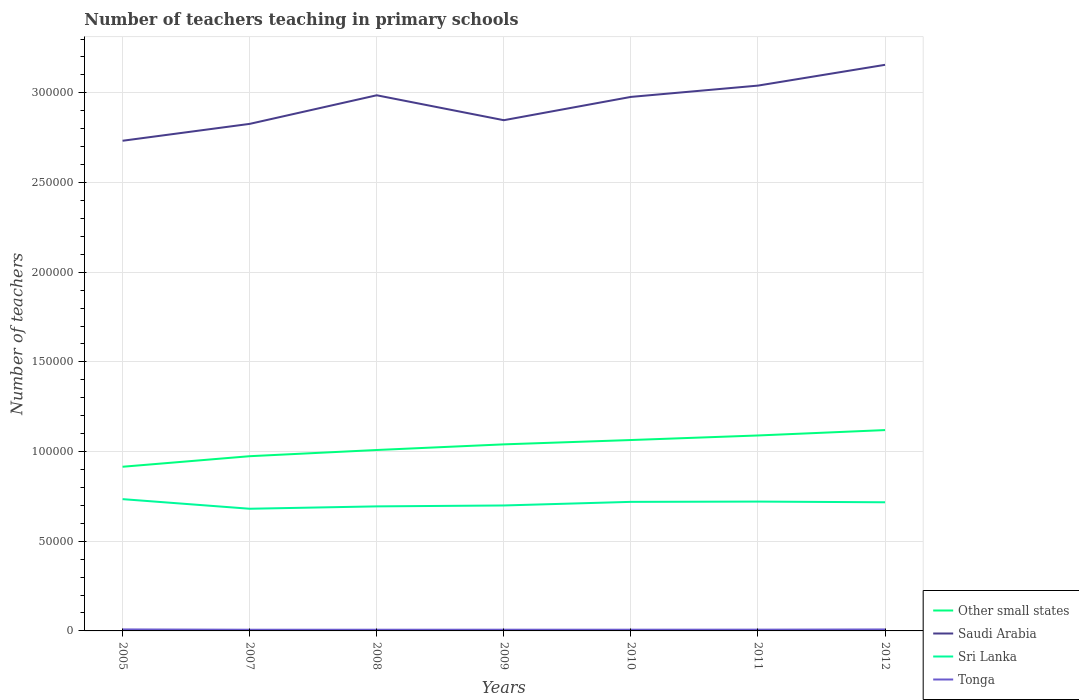How many different coloured lines are there?
Offer a very short reply. 4. Is the number of lines equal to the number of legend labels?
Give a very brief answer. Yes. Across all years, what is the maximum number of teachers teaching in primary schools in Other small states?
Your answer should be very brief. 9.15e+04. In which year was the number of teachers teaching in primary schools in Saudi Arabia maximum?
Give a very brief answer. 2005. What is the total number of teachers teaching in primary schools in Other small states in the graph?
Provide a short and direct response. -1.49e+04. What is the difference between the highest and the second highest number of teachers teaching in primary schools in Sri Lanka?
Provide a short and direct response. 5357. What is the difference between the highest and the lowest number of teachers teaching in primary schools in Saudi Arabia?
Your response must be concise. 4. Is the number of teachers teaching in primary schools in Tonga strictly greater than the number of teachers teaching in primary schools in Saudi Arabia over the years?
Your response must be concise. Yes. How many lines are there?
Your answer should be very brief. 4. How many years are there in the graph?
Make the answer very short. 7. Are the values on the major ticks of Y-axis written in scientific E-notation?
Your answer should be compact. No. Does the graph contain any zero values?
Ensure brevity in your answer.  No. Does the graph contain grids?
Keep it short and to the point. Yes. How are the legend labels stacked?
Offer a very short reply. Vertical. What is the title of the graph?
Give a very brief answer. Number of teachers teaching in primary schools. What is the label or title of the Y-axis?
Your response must be concise. Number of teachers. What is the Number of teachers of Other small states in 2005?
Your answer should be compact. 9.15e+04. What is the Number of teachers of Saudi Arabia in 2005?
Keep it short and to the point. 2.73e+05. What is the Number of teachers of Sri Lanka in 2005?
Offer a very short reply. 7.35e+04. What is the Number of teachers of Tonga in 2005?
Keep it short and to the point. 839. What is the Number of teachers in Other small states in 2007?
Your answer should be very brief. 9.74e+04. What is the Number of teachers of Saudi Arabia in 2007?
Keep it short and to the point. 2.83e+05. What is the Number of teachers in Sri Lanka in 2007?
Offer a terse response. 6.81e+04. What is the Number of teachers of Tonga in 2007?
Provide a succinct answer. 665. What is the Number of teachers of Other small states in 2008?
Ensure brevity in your answer.  1.01e+05. What is the Number of teachers in Saudi Arabia in 2008?
Give a very brief answer. 2.99e+05. What is the Number of teachers in Sri Lanka in 2008?
Keep it short and to the point. 6.94e+04. What is the Number of teachers of Tonga in 2008?
Your response must be concise. 665. What is the Number of teachers of Other small states in 2009?
Your response must be concise. 1.04e+05. What is the Number of teachers in Saudi Arabia in 2009?
Provide a succinct answer. 2.85e+05. What is the Number of teachers of Sri Lanka in 2009?
Provide a succinct answer. 6.99e+04. What is the Number of teachers of Tonga in 2009?
Keep it short and to the point. 680. What is the Number of teachers in Other small states in 2010?
Give a very brief answer. 1.06e+05. What is the Number of teachers in Saudi Arabia in 2010?
Your answer should be compact. 2.98e+05. What is the Number of teachers of Sri Lanka in 2010?
Your answer should be compact. 7.20e+04. What is the Number of teachers in Tonga in 2010?
Your response must be concise. 677. What is the Number of teachers of Other small states in 2011?
Provide a short and direct response. 1.09e+05. What is the Number of teachers in Saudi Arabia in 2011?
Offer a terse response. 3.04e+05. What is the Number of teachers of Sri Lanka in 2011?
Offer a very short reply. 7.21e+04. What is the Number of teachers in Tonga in 2011?
Keep it short and to the point. 706. What is the Number of teachers in Other small states in 2012?
Give a very brief answer. 1.12e+05. What is the Number of teachers of Saudi Arabia in 2012?
Ensure brevity in your answer.  3.16e+05. What is the Number of teachers of Sri Lanka in 2012?
Your answer should be compact. 7.17e+04. What is the Number of teachers in Tonga in 2012?
Give a very brief answer. 816. Across all years, what is the maximum Number of teachers in Other small states?
Offer a terse response. 1.12e+05. Across all years, what is the maximum Number of teachers in Saudi Arabia?
Offer a terse response. 3.16e+05. Across all years, what is the maximum Number of teachers of Sri Lanka?
Offer a terse response. 7.35e+04. Across all years, what is the maximum Number of teachers of Tonga?
Your response must be concise. 839. Across all years, what is the minimum Number of teachers in Other small states?
Ensure brevity in your answer.  9.15e+04. Across all years, what is the minimum Number of teachers of Saudi Arabia?
Provide a short and direct response. 2.73e+05. Across all years, what is the minimum Number of teachers in Sri Lanka?
Your answer should be very brief. 6.81e+04. Across all years, what is the minimum Number of teachers in Tonga?
Your answer should be compact. 665. What is the total Number of teachers of Other small states in the graph?
Ensure brevity in your answer.  7.21e+05. What is the total Number of teachers of Saudi Arabia in the graph?
Provide a short and direct response. 2.06e+06. What is the total Number of teachers in Sri Lanka in the graph?
Your answer should be very brief. 4.97e+05. What is the total Number of teachers of Tonga in the graph?
Your answer should be compact. 5048. What is the difference between the Number of teachers in Other small states in 2005 and that in 2007?
Your answer should be very brief. -5878.77. What is the difference between the Number of teachers in Saudi Arabia in 2005 and that in 2007?
Your answer should be compact. -9409. What is the difference between the Number of teachers in Sri Lanka in 2005 and that in 2007?
Give a very brief answer. 5357. What is the difference between the Number of teachers in Tonga in 2005 and that in 2007?
Give a very brief answer. 174. What is the difference between the Number of teachers in Other small states in 2005 and that in 2008?
Make the answer very short. -9336.92. What is the difference between the Number of teachers in Saudi Arabia in 2005 and that in 2008?
Make the answer very short. -2.54e+04. What is the difference between the Number of teachers of Sri Lanka in 2005 and that in 2008?
Provide a succinct answer. 4035. What is the difference between the Number of teachers in Tonga in 2005 and that in 2008?
Keep it short and to the point. 174. What is the difference between the Number of teachers of Other small states in 2005 and that in 2009?
Your answer should be very brief. -1.25e+04. What is the difference between the Number of teachers in Saudi Arabia in 2005 and that in 2009?
Your response must be concise. -1.15e+04. What is the difference between the Number of teachers of Sri Lanka in 2005 and that in 2009?
Your answer should be compact. 3523. What is the difference between the Number of teachers of Tonga in 2005 and that in 2009?
Your answer should be very brief. 159. What is the difference between the Number of teachers in Other small states in 2005 and that in 2010?
Provide a succinct answer. -1.49e+04. What is the difference between the Number of teachers in Saudi Arabia in 2005 and that in 2010?
Ensure brevity in your answer.  -2.44e+04. What is the difference between the Number of teachers in Sri Lanka in 2005 and that in 2010?
Make the answer very short. 1514. What is the difference between the Number of teachers in Tonga in 2005 and that in 2010?
Ensure brevity in your answer.  162. What is the difference between the Number of teachers in Other small states in 2005 and that in 2011?
Your response must be concise. -1.74e+04. What is the difference between the Number of teachers in Saudi Arabia in 2005 and that in 2011?
Your response must be concise. -3.08e+04. What is the difference between the Number of teachers in Sri Lanka in 2005 and that in 2011?
Your answer should be very brief. 1357. What is the difference between the Number of teachers in Tonga in 2005 and that in 2011?
Give a very brief answer. 133. What is the difference between the Number of teachers in Other small states in 2005 and that in 2012?
Your response must be concise. -2.04e+04. What is the difference between the Number of teachers in Saudi Arabia in 2005 and that in 2012?
Your response must be concise. -4.23e+04. What is the difference between the Number of teachers of Sri Lanka in 2005 and that in 2012?
Keep it short and to the point. 1750. What is the difference between the Number of teachers of Tonga in 2005 and that in 2012?
Provide a succinct answer. 23. What is the difference between the Number of teachers in Other small states in 2007 and that in 2008?
Provide a short and direct response. -3458.15. What is the difference between the Number of teachers in Saudi Arabia in 2007 and that in 2008?
Your answer should be compact. -1.59e+04. What is the difference between the Number of teachers in Sri Lanka in 2007 and that in 2008?
Your answer should be very brief. -1322. What is the difference between the Number of teachers of Other small states in 2007 and that in 2009?
Give a very brief answer. -6601.63. What is the difference between the Number of teachers of Saudi Arabia in 2007 and that in 2009?
Provide a short and direct response. -2053. What is the difference between the Number of teachers in Sri Lanka in 2007 and that in 2009?
Provide a succinct answer. -1834. What is the difference between the Number of teachers in Tonga in 2007 and that in 2009?
Your answer should be compact. -15. What is the difference between the Number of teachers of Other small states in 2007 and that in 2010?
Ensure brevity in your answer.  -9015.43. What is the difference between the Number of teachers of Saudi Arabia in 2007 and that in 2010?
Ensure brevity in your answer.  -1.50e+04. What is the difference between the Number of teachers in Sri Lanka in 2007 and that in 2010?
Your answer should be very brief. -3843. What is the difference between the Number of teachers of Other small states in 2007 and that in 2011?
Provide a short and direct response. -1.16e+04. What is the difference between the Number of teachers of Saudi Arabia in 2007 and that in 2011?
Your answer should be compact. -2.13e+04. What is the difference between the Number of teachers in Sri Lanka in 2007 and that in 2011?
Offer a very short reply. -4000. What is the difference between the Number of teachers of Tonga in 2007 and that in 2011?
Keep it short and to the point. -41. What is the difference between the Number of teachers of Other small states in 2007 and that in 2012?
Keep it short and to the point. -1.46e+04. What is the difference between the Number of teachers of Saudi Arabia in 2007 and that in 2012?
Make the answer very short. -3.29e+04. What is the difference between the Number of teachers of Sri Lanka in 2007 and that in 2012?
Provide a short and direct response. -3607. What is the difference between the Number of teachers in Tonga in 2007 and that in 2012?
Keep it short and to the point. -151. What is the difference between the Number of teachers of Other small states in 2008 and that in 2009?
Provide a succinct answer. -3143.48. What is the difference between the Number of teachers in Saudi Arabia in 2008 and that in 2009?
Provide a short and direct response. 1.39e+04. What is the difference between the Number of teachers in Sri Lanka in 2008 and that in 2009?
Give a very brief answer. -512. What is the difference between the Number of teachers in Tonga in 2008 and that in 2009?
Your response must be concise. -15. What is the difference between the Number of teachers of Other small states in 2008 and that in 2010?
Ensure brevity in your answer.  -5557.28. What is the difference between the Number of teachers in Saudi Arabia in 2008 and that in 2010?
Your answer should be very brief. 907. What is the difference between the Number of teachers in Sri Lanka in 2008 and that in 2010?
Your response must be concise. -2521. What is the difference between the Number of teachers of Other small states in 2008 and that in 2011?
Offer a terse response. -8101.96. What is the difference between the Number of teachers in Saudi Arabia in 2008 and that in 2011?
Keep it short and to the point. -5397. What is the difference between the Number of teachers of Sri Lanka in 2008 and that in 2011?
Provide a succinct answer. -2678. What is the difference between the Number of teachers of Tonga in 2008 and that in 2011?
Your response must be concise. -41. What is the difference between the Number of teachers of Other small states in 2008 and that in 2012?
Make the answer very short. -1.11e+04. What is the difference between the Number of teachers of Saudi Arabia in 2008 and that in 2012?
Provide a succinct answer. -1.70e+04. What is the difference between the Number of teachers in Sri Lanka in 2008 and that in 2012?
Keep it short and to the point. -2285. What is the difference between the Number of teachers of Tonga in 2008 and that in 2012?
Provide a short and direct response. -151. What is the difference between the Number of teachers of Other small states in 2009 and that in 2010?
Give a very brief answer. -2413.8. What is the difference between the Number of teachers in Saudi Arabia in 2009 and that in 2010?
Provide a succinct answer. -1.30e+04. What is the difference between the Number of teachers in Sri Lanka in 2009 and that in 2010?
Your response must be concise. -2009. What is the difference between the Number of teachers of Tonga in 2009 and that in 2010?
Give a very brief answer. 3. What is the difference between the Number of teachers of Other small states in 2009 and that in 2011?
Provide a succinct answer. -4958.48. What is the difference between the Number of teachers of Saudi Arabia in 2009 and that in 2011?
Provide a succinct answer. -1.93e+04. What is the difference between the Number of teachers of Sri Lanka in 2009 and that in 2011?
Offer a very short reply. -2166. What is the difference between the Number of teachers in Tonga in 2009 and that in 2011?
Your response must be concise. -26. What is the difference between the Number of teachers in Other small states in 2009 and that in 2012?
Provide a succinct answer. -7964.37. What is the difference between the Number of teachers in Saudi Arabia in 2009 and that in 2012?
Offer a very short reply. -3.09e+04. What is the difference between the Number of teachers in Sri Lanka in 2009 and that in 2012?
Provide a succinct answer. -1773. What is the difference between the Number of teachers in Tonga in 2009 and that in 2012?
Offer a terse response. -136. What is the difference between the Number of teachers in Other small states in 2010 and that in 2011?
Your answer should be compact. -2544.68. What is the difference between the Number of teachers in Saudi Arabia in 2010 and that in 2011?
Your answer should be very brief. -6304. What is the difference between the Number of teachers of Sri Lanka in 2010 and that in 2011?
Ensure brevity in your answer.  -157. What is the difference between the Number of teachers of Other small states in 2010 and that in 2012?
Keep it short and to the point. -5550.57. What is the difference between the Number of teachers of Saudi Arabia in 2010 and that in 2012?
Offer a terse response. -1.79e+04. What is the difference between the Number of teachers in Sri Lanka in 2010 and that in 2012?
Your answer should be compact. 236. What is the difference between the Number of teachers in Tonga in 2010 and that in 2012?
Provide a succinct answer. -139. What is the difference between the Number of teachers of Other small states in 2011 and that in 2012?
Offer a very short reply. -3005.89. What is the difference between the Number of teachers in Saudi Arabia in 2011 and that in 2012?
Offer a very short reply. -1.16e+04. What is the difference between the Number of teachers in Sri Lanka in 2011 and that in 2012?
Your answer should be compact. 393. What is the difference between the Number of teachers of Tonga in 2011 and that in 2012?
Your answer should be very brief. -110. What is the difference between the Number of teachers in Other small states in 2005 and the Number of teachers in Saudi Arabia in 2007?
Keep it short and to the point. -1.91e+05. What is the difference between the Number of teachers in Other small states in 2005 and the Number of teachers in Sri Lanka in 2007?
Your answer should be very brief. 2.34e+04. What is the difference between the Number of teachers in Other small states in 2005 and the Number of teachers in Tonga in 2007?
Provide a succinct answer. 9.09e+04. What is the difference between the Number of teachers of Saudi Arabia in 2005 and the Number of teachers of Sri Lanka in 2007?
Provide a short and direct response. 2.05e+05. What is the difference between the Number of teachers of Saudi Arabia in 2005 and the Number of teachers of Tonga in 2007?
Provide a succinct answer. 2.73e+05. What is the difference between the Number of teachers in Sri Lanka in 2005 and the Number of teachers in Tonga in 2007?
Your response must be concise. 7.28e+04. What is the difference between the Number of teachers of Other small states in 2005 and the Number of teachers of Saudi Arabia in 2008?
Your answer should be very brief. -2.07e+05. What is the difference between the Number of teachers of Other small states in 2005 and the Number of teachers of Sri Lanka in 2008?
Provide a succinct answer. 2.21e+04. What is the difference between the Number of teachers in Other small states in 2005 and the Number of teachers in Tonga in 2008?
Ensure brevity in your answer.  9.09e+04. What is the difference between the Number of teachers of Saudi Arabia in 2005 and the Number of teachers of Sri Lanka in 2008?
Your answer should be very brief. 2.04e+05. What is the difference between the Number of teachers in Saudi Arabia in 2005 and the Number of teachers in Tonga in 2008?
Ensure brevity in your answer.  2.73e+05. What is the difference between the Number of teachers of Sri Lanka in 2005 and the Number of teachers of Tonga in 2008?
Give a very brief answer. 7.28e+04. What is the difference between the Number of teachers of Other small states in 2005 and the Number of teachers of Saudi Arabia in 2009?
Ensure brevity in your answer.  -1.93e+05. What is the difference between the Number of teachers in Other small states in 2005 and the Number of teachers in Sri Lanka in 2009?
Make the answer very short. 2.16e+04. What is the difference between the Number of teachers of Other small states in 2005 and the Number of teachers of Tonga in 2009?
Make the answer very short. 9.09e+04. What is the difference between the Number of teachers of Saudi Arabia in 2005 and the Number of teachers of Sri Lanka in 2009?
Ensure brevity in your answer.  2.03e+05. What is the difference between the Number of teachers of Saudi Arabia in 2005 and the Number of teachers of Tonga in 2009?
Ensure brevity in your answer.  2.73e+05. What is the difference between the Number of teachers in Sri Lanka in 2005 and the Number of teachers in Tonga in 2009?
Your response must be concise. 7.28e+04. What is the difference between the Number of teachers of Other small states in 2005 and the Number of teachers of Saudi Arabia in 2010?
Your answer should be very brief. -2.06e+05. What is the difference between the Number of teachers in Other small states in 2005 and the Number of teachers in Sri Lanka in 2010?
Make the answer very short. 1.96e+04. What is the difference between the Number of teachers in Other small states in 2005 and the Number of teachers in Tonga in 2010?
Provide a short and direct response. 9.09e+04. What is the difference between the Number of teachers of Saudi Arabia in 2005 and the Number of teachers of Sri Lanka in 2010?
Ensure brevity in your answer.  2.01e+05. What is the difference between the Number of teachers in Saudi Arabia in 2005 and the Number of teachers in Tonga in 2010?
Ensure brevity in your answer.  2.73e+05. What is the difference between the Number of teachers of Sri Lanka in 2005 and the Number of teachers of Tonga in 2010?
Offer a very short reply. 7.28e+04. What is the difference between the Number of teachers in Other small states in 2005 and the Number of teachers in Saudi Arabia in 2011?
Provide a short and direct response. -2.13e+05. What is the difference between the Number of teachers of Other small states in 2005 and the Number of teachers of Sri Lanka in 2011?
Provide a succinct answer. 1.94e+04. What is the difference between the Number of teachers in Other small states in 2005 and the Number of teachers in Tonga in 2011?
Your answer should be very brief. 9.08e+04. What is the difference between the Number of teachers of Saudi Arabia in 2005 and the Number of teachers of Sri Lanka in 2011?
Keep it short and to the point. 2.01e+05. What is the difference between the Number of teachers of Saudi Arabia in 2005 and the Number of teachers of Tonga in 2011?
Your answer should be compact. 2.73e+05. What is the difference between the Number of teachers of Sri Lanka in 2005 and the Number of teachers of Tonga in 2011?
Your response must be concise. 7.28e+04. What is the difference between the Number of teachers in Other small states in 2005 and the Number of teachers in Saudi Arabia in 2012?
Make the answer very short. -2.24e+05. What is the difference between the Number of teachers in Other small states in 2005 and the Number of teachers in Sri Lanka in 2012?
Make the answer very short. 1.98e+04. What is the difference between the Number of teachers in Other small states in 2005 and the Number of teachers in Tonga in 2012?
Provide a short and direct response. 9.07e+04. What is the difference between the Number of teachers in Saudi Arabia in 2005 and the Number of teachers in Sri Lanka in 2012?
Your response must be concise. 2.02e+05. What is the difference between the Number of teachers of Saudi Arabia in 2005 and the Number of teachers of Tonga in 2012?
Give a very brief answer. 2.72e+05. What is the difference between the Number of teachers in Sri Lanka in 2005 and the Number of teachers in Tonga in 2012?
Offer a terse response. 7.27e+04. What is the difference between the Number of teachers in Other small states in 2007 and the Number of teachers in Saudi Arabia in 2008?
Your answer should be very brief. -2.01e+05. What is the difference between the Number of teachers in Other small states in 2007 and the Number of teachers in Sri Lanka in 2008?
Give a very brief answer. 2.80e+04. What is the difference between the Number of teachers in Other small states in 2007 and the Number of teachers in Tonga in 2008?
Give a very brief answer. 9.67e+04. What is the difference between the Number of teachers of Saudi Arabia in 2007 and the Number of teachers of Sri Lanka in 2008?
Your response must be concise. 2.13e+05. What is the difference between the Number of teachers of Saudi Arabia in 2007 and the Number of teachers of Tonga in 2008?
Ensure brevity in your answer.  2.82e+05. What is the difference between the Number of teachers in Sri Lanka in 2007 and the Number of teachers in Tonga in 2008?
Ensure brevity in your answer.  6.74e+04. What is the difference between the Number of teachers in Other small states in 2007 and the Number of teachers in Saudi Arabia in 2009?
Your response must be concise. -1.87e+05. What is the difference between the Number of teachers of Other small states in 2007 and the Number of teachers of Sri Lanka in 2009?
Give a very brief answer. 2.75e+04. What is the difference between the Number of teachers of Other small states in 2007 and the Number of teachers of Tonga in 2009?
Provide a succinct answer. 9.67e+04. What is the difference between the Number of teachers of Saudi Arabia in 2007 and the Number of teachers of Sri Lanka in 2009?
Ensure brevity in your answer.  2.13e+05. What is the difference between the Number of teachers of Saudi Arabia in 2007 and the Number of teachers of Tonga in 2009?
Your answer should be compact. 2.82e+05. What is the difference between the Number of teachers in Sri Lanka in 2007 and the Number of teachers in Tonga in 2009?
Your answer should be compact. 6.74e+04. What is the difference between the Number of teachers in Other small states in 2007 and the Number of teachers in Saudi Arabia in 2010?
Provide a succinct answer. -2.00e+05. What is the difference between the Number of teachers in Other small states in 2007 and the Number of teachers in Sri Lanka in 2010?
Make the answer very short. 2.55e+04. What is the difference between the Number of teachers of Other small states in 2007 and the Number of teachers of Tonga in 2010?
Make the answer very short. 9.67e+04. What is the difference between the Number of teachers of Saudi Arabia in 2007 and the Number of teachers of Sri Lanka in 2010?
Make the answer very short. 2.11e+05. What is the difference between the Number of teachers in Saudi Arabia in 2007 and the Number of teachers in Tonga in 2010?
Your answer should be very brief. 2.82e+05. What is the difference between the Number of teachers in Sri Lanka in 2007 and the Number of teachers in Tonga in 2010?
Your answer should be very brief. 6.74e+04. What is the difference between the Number of teachers of Other small states in 2007 and the Number of teachers of Saudi Arabia in 2011?
Keep it short and to the point. -2.07e+05. What is the difference between the Number of teachers of Other small states in 2007 and the Number of teachers of Sri Lanka in 2011?
Offer a terse response. 2.53e+04. What is the difference between the Number of teachers of Other small states in 2007 and the Number of teachers of Tonga in 2011?
Your response must be concise. 9.67e+04. What is the difference between the Number of teachers in Saudi Arabia in 2007 and the Number of teachers in Sri Lanka in 2011?
Provide a short and direct response. 2.11e+05. What is the difference between the Number of teachers of Saudi Arabia in 2007 and the Number of teachers of Tonga in 2011?
Offer a terse response. 2.82e+05. What is the difference between the Number of teachers of Sri Lanka in 2007 and the Number of teachers of Tonga in 2011?
Ensure brevity in your answer.  6.74e+04. What is the difference between the Number of teachers in Other small states in 2007 and the Number of teachers in Saudi Arabia in 2012?
Make the answer very short. -2.18e+05. What is the difference between the Number of teachers in Other small states in 2007 and the Number of teachers in Sri Lanka in 2012?
Offer a very short reply. 2.57e+04. What is the difference between the Number of teachers of Other small states in 2007 and the Number of teachers of Tonga in 2012?
Your response must be concise. 9.66e+04. What is the difference between the Number of teachers of Saudi Arabia in 2007 and the Number of teachers of Sri Lanka in 2012?
Make the answer very short. 2.11e+05. What is the difference between the Number of teachers in Saudi Arabia in 2007 and the Number of teachers in Tonga in 2012?
Your answer should be compact. 2.82e+05. What is the difference between the Number of teachers in Sri Lanka in 2007 and the Number of teachers in Tonga in 2012?
Give a very brief answer. 6.73e+04. What is the difference between the Number of teachers in Other small states in 2008 and the Number of teachers in Saudi Arabia in 2009?
Your response must be concise. -1.84e+05. What is the difference between the Number of teachers in Other small states in 2008 and the Number of teachers in Sri Lanka in 2009?
Provide a short and direct response. 3.09e+04. What is the difference between the Number of teachers of Other small states in 2008 and the Number of teachers of Tonga in 2009?
Provide a short and direct response. 1.00e+05. What is the difference between the Number of teachers of Saudi Arabia in 2008 and the Number of teachers of Sri Lanka in 2009?
Your response must be concise. 2.29e+05. What is the difference between the Number of teachers in Saudi Arabia in 2008 and the Number of teachers in Tonga in 2009?
Give a very brief answer. 2.98e+05. What is the difference between the Number of teachers in Sri Lanka in 2008 and the Number of teachers in Tonga in 2009?
Provide a short and direct response. 6.88e+04. What is the difference between the Number of teachers in Other small states in 2008 and the Number of teachers in Saudi Arabia in 2010?
Provide a succinct answer. -1.97e+05. What is the difference between the Number of teachers of Other small states in 2008 and the Number of teachers of Sri Lanka in 2010?
Ensure brevity in your answer.  2.89e+04. What is the difference between the Number of teachers of Other small states in 2008 and the Number of teachers of Tonga in 2010?
Provide a short and direct response. 1.00e+05. What is the difference between the Number of teachers in Saudi Arabia in 2008 and the Number of teachers in Sri Lanka in 2010?
Your answer should be compact. 2.27e+05. What is the difference between the Number of teachers in Saudi Arabia in 2008 and the Number of teachers in Tonga in 2010?
Ensure brevity in your answer.  2.98e+05. What is the difference between the Number of teachers of Sri Lanka in 2008 and the Number of teachers of Tonga in 2010?
Keep it short and to the point. 6.88e+04. What is the difference between the Number of teachers in Other small states in 2008 and the Number of teachers in Saudi Arabia in 2011?
Give a very brief answer. -2.03e+05. What is the difference between the Number of teachers in Other small states in 2008 and the Number of teachers in Sri Lanka in 2011?
Your answer should be very brief. 2.88e+04. What is the difference between the Number of teachers of Other small states in 2008 and the Number of teachers of Tonga in 2011?
Provide a succinct answer. 1.00e+05. What is the difference between the Number of teachers of Saudi Arabia in 2008 and the Number of teachers of Sri Lanka in 2011?
Give a very brief answer. 2.27e+05. What is the difference between the Number of teachers in Saudi Arabia in 2008 and the Number of teachers in Tonga in 2011?
Your answer should be very brief. 2.98e+05. What is the difference between the Number of teachers in Sri Lanka in 2008 and the Number of teachers in Tonga in 2011?
Your answer should be compact. 6.87e+04. What is the difference between the Number of teachers in Other small states in 2008 and the Number of teachers in Saudi Arabia in 2012?
Your response must be concise. -2.15e+05. What is the difference between the Number of teachers in Other small states in 2008 and the Number of teachers in Sri Lanka in 2012?
Provide a short and direct response. 2.92e+04. What is the difference between the Number of teachers in Other small states in 2008 and the Number of teachers in Tonga in 2012?
Offer a very short reply. 1.00e+05. What is the difference between the Number of teachers of Saudi Arabia in 2008 and the Number of teachers of Sri Lanka in 2012?
Provide a succinct answer. 2.27e+05. What is the difference between the Number of teachers in Saudi Arabia in 2008 and the Number of teachers in Tonga in 2012?
Provide a succinct answer. 2.98e+05. What is the difference between the Number of teachers of Sri Lanka in 2008 and the Number of teachers of Tonga in 2012?
Give a very brief answer. 6.86e+04. What is the difference between the Number of teachers in Other small states in 2009 and the Number of teachers in Saudi Arabia in 2010?
Your answer should be very brief. -1.94e+05. What is the difference between the Number of teachers of Other small states in 2009 and the Number of teachers of Sri Lanka in 2010?
Offer a terse response. 3.21e+04. What is the difference between the Number of teachers of Other small states in 2009 and the Number of teachers of Tonga in 2010?
Make the answer very short. 1.03e+05. What is the difference between the Number of teachers of Saudi Arabia in 2009 and the Number of teachers of Sri Lanka in 2010?
Offer a very short reply. 2.13e+05. What is the difference between the Number of teachers of Saudi Arabia in 2009 and the Number of teachers of Tonga in 2010?
Provide a short and direct response. 2.84e+05. What is the difference between the Number of teachers of Sri Lanka in 2009 and the Number of teachers of Tonga in 2010?
Provide a short and direct response. 6.93e+04. What is the difference between the Number of teachers of Other small states in 2009 and the Number of teachers of Saudi Arabia in 2011?
Ensure brevity in your answer.  -2.00e+05. What is the difference between the Number of teachers of Other small states in 2009 and the Number of teachers of Sri Lanka in 2011?
Offer a very short reply. 3.19e+04. What is the difference between the Number of teachers of Other small states in 2009 and the Number of teachers of Tonga in 2011?
Ensure brevity in your answer.  1.03e+05. What is the difference between the Number of teachers in Saudi Arabia in 2009 and the Number of teachers in Sri Lanka in 2011?
Provide a short and direct response. 2.13e+05. What is the difference between the Number of teachers of Saudi Arabia in 2009 and the Number of teachers of Tonga in 2011?
Keep it short and to the point. 2.84e+05. What is the difference between the Number of teachers of Sri Lanka in 2009 and the Number of teachers of Tonga in 2011?
Offer a terse response. 6.92e+04. What is the difference between the Number of teachers in Other small states in 2009 and the Number of teachers in Saudi Arabia in 2012?
Your response must be concise. -2.12e+05. What is the difference between the Number of teachers of Other small states in 2009 and the Number of teachers of Sri Lanka in 2012?
Your response must be concise. 3.23e+04. What is the difference between the Number of teachers in Other small states in 2009 and the Number of teachers in Tonga in 2012?
Keep it short and to the point. 1.03e+05. What is the difference between the Number of teachers of Saudi Arabia in 2009 and the Number of teachers of Sri Lanka in 2012?
Ensure brevity in your answer.  2.13e+05. What is the difference between the Number of teachers of Saudi Arabia in 2009 and the Number of teachers of Tonga in 2012?
Provide a succinct answer. 2.84e+05. What is the difference between the Number of teachers of Sri Lanka in 2009 and the Number of teachers of Tonga in 2012?
Provide a short and direct response. 6.91e+04. What is the difference between the Number of teachers in Other small states in 2010 and the Number of teachers in Saudi Arabia in 2011?
Keep it short and to the point. -1.98e+05. What is the difference between the Number of teachers of Other small states in 2010 and the Number of teachers of Sri Lanka in 2011?
Ensure brevity in your answer.  3.43e+04. What is the difference between the Number of teachers in Other small states in 2010 and the Number of teachers in Tonga in 2011?
Your answer should be compact. 1.06e+05. What is the difference between the Number of teachers of Saudi Arabia in 2010 and the Number of teachers of Sri Lanka in 2011?
Ensure brevity in your answer.  2.26e+05. What is the difference between the Number of teachers of Saudi Arabia in 2010 and the Number of teachers of Tonga in 2011?
Ensure brevity in your answer.  2.97e+05. What is the difference between the Number of teachers of Sri Lanka in 2010 and the Number of teachers of Tonga in 2011?
Ensure brevity in your answer.  7.13e+04. What is the difference between the Number of teachers of Other small states in 2010 and the Number of teachers of Saudi Arabia in 2012?
Offer a terse response. -2.09e+05. What is the difference between the Number of teachers in Other small states in 2010 and the Number of teachers in Sri Lanka in 2012?
Offer a terse response. 3.47e+04. What is the difference between the Number of teachers in Other small states in 2010 and the Number of teachers in Tonga in 2012?
Give a very brief answer. 1.06e+05. What is the difference between the Number of teachers in Saudi Arabia in 2010 and the Number of teachers in Sri Lanka in 2012?
Keep it short and to the point. 2.26e+05. What is the difference between the Number of teachers of Saudi Arabia in 2010 and the Number of teachers of Tonga in 2012?
Keep it short and to the point. 2.97e+05. What is the difference between the Number of teachers in Sri Lanka in 2010 and the Number of teachers in Tonga in 2012?
Ensure brevity in your answer.  7.11e+04. What is the difference between the Number of teachers in Other small states in 2011 and the Number of teachers in Saudi Arabia in 2012?
Keep it short and to the point. -2.07e+05. What is the difference between the Number of teachers in Other small states in 2011 and the Number of teachers in Sri Lanka in 2012?
Offer a terse response. 3.73e+04. What is the difference between the Number of teachers in Other small states in 2011 and the Number of teachers in Tonga in 2012?
Your answer should be compact. 1.08e+05. What is the difference between the Number of teachers of Saudi Arabia in 2011 and the Number of teachers of Sri Lanka in 2012?
Make the answer very short. 2.32e+05. What is the difference between the Number of teachers of Saudi Arabia in 2011 and the Number of teachers of Tonga in 2012?
Provide a succinct answer. 3.03e+05. What is the difference between the Number of teachers in Sri Lanka in 2011 and the Number of teachers in Tonga in 2012?
Your answer should be very brief. 7.13e+04. What is the average Number of teachers of Other small states per year?
Your answer should be compact. 1.03e+05. What is the average Number of teachers in Saudi Arabia per year?
Offer a very short reply. 2.94e+05. What is the average Number of teachers in Sri Lanka per year?
Provide a succinct answer. 7.10e+04. What is the average Number of teachers in Tonga per year?
Give a very brief answer. 721.14. In the year 2005, what is the difference between the Number of teachers of Other small states and Number of teachers of Saudi Arabia?
Make the answer very short. -1.82e+05. In the year 2005, what is the difference between the Number of teachers of Other small states and Number of teachers of Sri Lanka?
Offer a terse response. 1.81e+04. In the year 2005, what is the difference between the Number of teachers in Other small states and Number of teachers in Tonga?
Give a very brief answer. 9.07e+04. In the year 2005, what is the difference between the Number of teachers in Saudi Arabia and Number of teachers in Sri Lanka?
Offer a terse response. 2.00e+05. In the year 2005, what is the difference between the Number of teachers in Saudi Arabia and Number of teachers in Tonga?
Ensure brevity in your answer.  2.72e+05. In the year 2005, what is the difference between the Number of teachers of Sri Lanka and Number of teachers of Tonga?
Your answer should be compact. 7.26e+04. In the year 2007, what is the difference between the Number of teachers of Other small states and Number of teachers of Saudi Arabia?
Give a very brief answer. -1.85e+05. In the year 2007, what is the difference between the Number of teachers in Other small states and Number of teachers in Sri Lanka?
Give a very brief answer. 2.93e+04. In the year 2007, what is the difference between the Number of teachers of Other small states and Number of teachers of Tonga?
Offer a very short reply. 9.67e+04. In the year 2007, what is the difference between the Number of teachers of Saudi Arabia and Number of teachers of Sri Lanka?
Provide a short and direct response. 2.15e+05. In the year 2007, what is the difference between the Number of teachers in Saudi Arabia and Number of teachers in Tonga?
Your response must be concise. 2.82e+05. In the year 2007, what is the difference between the Number of teachers of Sri Lanka and Number of teachers of Tonga?
Offer a very short reply. 6.74e+04. In the year 2008, what is the difference between the Number of teachers in Other small states and Number of teachers in Saudi Arabia?
Give a very brief answer. -1.98e+05. In the year 2008, what is the difference between the Number of teachers of Other small states and Number of teachers of Sri Lanka?
Your response must be concise. 3.14e+04. In the year 2008, what is the difference between the Number of teachers in Other small states and Number of teachers in Tonga?
Your answer should be very brief. 1.00e+05. In the year 2008, what is the difference between the Number of teachers of Saudi Arabia and Number of teachers of Sri Lanka?
Ensure brevity in your answer.  2.29e+05. In the year 2008, what is the difference between the Number of teachers of Saudi Arabia and Number of teachers of Tonga?
Ensure brevity in your answer.  2.98e+05. In the year 2008, what is the difference between the Number of teachers of Sri Lanka and Number of teachers of Tonga?
Make the answer very short. 6.88e+04. In the year 2009, what is the difference between the Number of teachers in Other small states and Number of teachers in Saudi Arabia?
Provide a short and direct response. -1.81e+05. In the year 2009, what is the difference between the Number of teachers of Other small states and Number of teachers of Sri Lanka?
Keep it short and to the point. 3.41e+04. In the year 2009, what is the difference between the Number of teachers in Other small states and Number of teachers in Tonga?
Offer a terse response. 1.03e+05. In the year 2009, what is the difference between the Number of teachers in Saudi Arabia and Number of teachers in Sri Lanka?
Your answer should be very brief. 2.15e+05. In the year 2009, what is the difference between the Number of teachers of Saudi Arabia and Number of teachers of Tonga?
Your response must be concise. 2.84e+05. In the year 2009, what is the difference between the Number of teachers in Sri Lanka and Number of teachers in Tonga?
Make the answer very short. 6.93e+04. In the year 2010, what is the difference between the Number of teachers of Other small states and Number of teachers of Saudi Arabia?
Make the answer very short. -1.91e+05. In the year 2010, what is the difference between the Number of teachers of Other small states and Number of teachers of Sri Lanka?
Make the answer very short. 3.45e+04. In the year 2010, what is the difference between the Number of teachers of Other small states and Number of teachers of Tonga?
Offer a terse response. 1.06e+05. In the year 2010, what is the difference between the Number of teachers in Saudi Arabia and Number of teachers in Sri Lanka?
Offer a very short reply. 2.26e+05. In the year 2010, what is the difference between the Number of teachers in Saudi Arabia and Number of teachers in Tonga?
Your answer should be compact. 2.97e+05. In the year 2010, what is the difference between the Number of teachers of Sri Lanka and Number of teachers of Tonga?
Offer a terse response. 7.13e+04. In the year 2011, what is the difference between the Number of teachers of Other small states and Number of teachers of Saudi Arabia?
Provide a succinct answer. -1.95e+05. In the year 2011, what is the difference between the Number of teachers in Other small states and Number of teachers in Sri Lanka?
Offer a very short reply. 3.69e+04. In the year 2011, what is the difference between the Number of teachers in Other small states and Number of teachers in Tonga?
Give a very brief answer. 1.08e+05. In the year 2011, what is the difference between the Number of teachers in Saudi Arabia and Number of teachers in Sri Lanka?
Make the answer very short. 2.32e+05. In the year 2011, what is the difference between the Number of teachers in Saudi Arabia and Number of teachers in Tonga?
Your response must be concise. 3.03e+05. In the year 2011, what is the difference between the Number of teachers in Sri Lanka and Number of teachers in Tonga?
Your response must be concise. 7.14e+04. In the year 2012, what is the difference between the Number of teachers in Other small states and Number of teachers in Saudi Arabia?
Your response must be concise. -2.04e+05. In the year 2012, what is the difference between the Number of teachers of Other small states and Number of teachers of Sri Lanka?
Your answer should be compact. 4.03e+04. In the year 2012, what is the difference between the Number of teachers in Other small states and Number of teachers in Tonga?
Ensure brevity in your answer.  1.11e+05. In the year 2012, what is the difference between the Number of teachers in Saudi Arabia and Number of teachers in Sri Lanka?
Offer a very short reply. 2.44e+05. In the year 2012, what is the difference between the Number of teachers of Saudi Arabia and Number of teachers of Tonga?
Keep it short and to the point. 3.15e+05. In the year 2012, what is the difference between the Number of teachers in Sri Lanka and Number of teachers in Tonga?
Ensure brevity in your answer.  7.09e+04. What is the ratio of the Number of teachers in Other small states in 2005 to that in 2007?
Make the answer very short. 0.94. What is the ratio of the Number of teachers of Saudi Arabia in 2005 to that in 2007?
Your answer should be compact. 0.97. What is the ratio of the Number of teachers in Sri Lanka in 2005 to that in 2007?
Give a very brief answer. 1.08. What is the ratio of the Number of teachers of Tonga in 2005 to that in 2007?
Provide a succinct answer. 1.26. What is the ratio of the Number of teachers in Other small states in 2005 to that in 2008?
Provide a short and direct response. 0.91. What is the ratio of the Number of teachers of Saudi Arabia in 2005 to that in 2008?
Provide a short and direct response. 0.92. What is the ratio of the Number of teachers in Sri Lanka in 2005 to that in 2008?
Provide a short and direct response. 1.06. What is the ratio of the Number of teachers of Tonga in 2005 to that in 2008?
Provide a succinct answer. 1.26. What is the ratio of the Number of teachers of Other small states in 2005 to that in 2009?
Your answer should be compact. 0.88. What is the ratio of the Number of teachers of Saudi Arabia in 2005 to that in 2009?
Provide a short and direct response. 0.96. What is the ratio of the Number of teachers in Sri Lanka in 2005 to that in 2009?
Your response must be concise. 1.05. What is the ratio of the Number of teachers in Tonga in 2005 to that in 2009?
Keep it short and to the point. 1.23. What is the ratio of the Number of teachers of Other small states in 2005 to that in 2010?
Offer a terse response. 0.86. What is the ratio of the Number of teachers of Saudi Arabia in 2005 to that in 2010?
Your response must be concise. 0.92. What is the ratio of the Number of teachers of Sri Lanka in 2005 to that in 2010?
Give a very brief answer. 1.02. What is the ratio of the Number of teachers of Tonga in 2005 to that in 2010?
Make the answer very short. 1.24. What is the ratio of the Number of teachers in Other small states in 2005 to that in 2011?
Keep it short and to the point. 0.84. What is the ratio of the Number of teachers of Saudi Arabia in 2005 to that in 2011?
Keep it short and to the point. 0.9. What is the ratio of the Number of teachers in Sri Lanka in 2005 to that in 2011?
Give a very brief answer. 1.02. What is the ratio of the Number of teachers of Tonga in 2005 to that in 2011?
Ensure brevity in your answer.  1.19. What is the ratio of the Number of teachers in Other small states in 2005 to that in 2012?
Offer a very short reply. 0.82. What is the ratio of the Number of teachers of Saudi Arabia in 2005 to that in 2012?
Your answer should be very brief. 0.87. What is the ratio of the Number of teachers of Sri Lanka in 2005 to that in 2012?
Keep it short and to the point. 1.02. What is the ratio of the Number of teachers in Tonga in 2005 to that in 2012?
Your response must be concise. 1.03. What is the ratio of the Number of teachers in Other small states in 2007 to that in 2008?
Make the answer very short. 0.97. What is the ratio of the Number of teachers of Saudi Arabia in 2007 to that in 2008?
Offer a terse response. 0.95. What is the ratio of the Number of teachers of Sri Lanka in 2007 to that in 2008?
Ensure brevity in your answer.  0.98. What is the ratio of the Number of teachers of Tonga in 2007 to that in 2008?
Offer a very short reply. 1. What is the ratio of the Number of teachers of Other small states in 2007 to that in 2009?
Ensure brevity in your answer.  0.94. What is the ratio of the Number of teachers in Sri Lanka in 2007 to that in 2009?
Keep it short and to the point. 0.97. What is the ratio of the Number of teachers in Tonga in 2007 to that in 2009?
Provide a succinct answer. 0.98. What is the ratio of the Number of teachers in Other small states in 2007 to that in 2010?
Your response must be concise. 0.92. What is the ratio of the Number of teachers in Saudi Arabia in 2007 to that in 2010?
Offer a terse response. 0.95. What is the ratio of the Number of teachers in Sri Lanka in 2007 to that in 2010?
Make the answer very short. 0.95. What is the ratio of the Number of teachers in Tonga in 2007 to that in 2010?
Provide a short and direct response. 0.98. What is the ratio of the Number of teachers of Other small states in 2007 to that in 2011?
Give a very brief answer. 0.89. What is the ratio of the Number of teachers in Saudi Arabia in 2007 to that in 2011?
Give a very brief answer. 0.93. What is the ratio of the Number of teachers of Sri Lanka in 2007 to that in 2011?
Keep it short and to the point. 0.94. What is the ratio of the Number of teachers of Tonga in 2007 to that in 2011?
Your response must be concise. 0.94. What is the ratio of the Number of teachers in Other small states in 2007 to that in 2012?
Offer a very short reply. 0.87. What is the ratio of the Number of teachers in Saudi Arabia in 2007 to that in 2012?
Your response must be concise. 0.9. What is the ratio of the Number of teachers in Sri Lanka in 2007 to that in 2012?
Your response must be concise. 0.95. What is the ratio of the Number of teachers of Tonga in 2007 to that in 2012?
Make the answer very short. 0.81. What is the ratio of the Number of teachers of Other small states in 2008 to that in 2009?
Provide a short and direct response. 0.97. What is the ratio of the Number of teachers of Saudi Arabia in 2008 to that in 2009?
Your response must be concise. 1.05. What is the ratio of the Number of teachers in Sri Lanka in 2008 to that in 2009?
Keep it short and to the point. 0.99. What is the ratio of the Number of teachers of Tonga in 2008 to that in 2009?
Make the answer very short. 0.98. What is the ratio of the Number of teachers of Other small states in 2008 to that in 2010?
Your answer should be compact. 0.95. What is the ratio of the Number of teachers of Sri Lanka in 2008 to that in 2010?
Keep it short and to the point. 0.96. What is the ratio of the Number of teachers in Tonga in 2008 to that in 2010?
Ensure brevity in your answer.  0.98. What is the ratio of the Number of teachers of Other small states in 2008 to that in 2011?
Give a very brief answer. 0.93. What is the ratio of the Number of teachers of Saudi Arabia in 2008 to that in 2011?
Provide a succinct answer. 0.98. What is the ratio of the Number of teachers of Sri Lanka in 2008 to that in 2011?
Give a very brief answer. 0.96. What is the ratio of the Number of teachers in Tonga in 2008 to that in 2011?
Your answer should be compact. 0.94. What is the ratio of the Number of teachers of Other small states in 2008 to that in 2012?
Give a very brief answer. 0.9. What is the ratio of the Number of teachers in Saudi Arabia in 2008 to that in 2012?
Provide a short and direct response. 0.95. What is the ratio of the Number of teachers of Sri Lanka in 2008 to that in 2012?
Your answer should be compact. 0.97. What is the ratio of the Number of teachers of Tonga in 2008 to that in 2012?
Offer a terse response. 0.81. What is the ratio of the Number of teachers in Other small states in 2009 to that in 2010?
Your answer should be very brief. 0.98. What is the ratio of the Number of teachers in Saudi Arabia in 2009 to that in 2010?
Your answer should be compact. 0.96. What is the ratio of the Number of teachers in Sri Lanka in 2009 to that in 2010?
Your answer should be compact. 0.97. What is the ratio of the Number of teachers in Other small states in 2009 to that in 2011?
Make the answer very short. 0.95. What is the ratio of the Number of teachers of Saudi Arabia in 2009 to that in 2011?
Offer a very short reply. 0.94. What is the ratio of the Number of teachers of Tonga in 2009 to that in 2011?
Make the answer very short. 0.96. What is the ratio of the Number of teachers of Other small states in 2009 to that in 2012?
Your answer should be very brief. 0.93. What is the ratio of the Number of teachers of Saudi Arabia in 2009 to that in 2012?
Your answer should be compact. 0.9. What is the ratio of the Number of teachers in Sri Lanka in 2009 to that in 2012?
Provide a succinct answer. 0.98. What is the ratio of the Number of teachers of Other small states in 2010 to that in 2011?
Your answer should be very brief. 0.98. What is the ratio of the Number of teachers of Saudi Arabia in 2010 to that in 2011?
Offer a terse response. 0.98. What is the ratio of the Number of teachers in Tonga in 2010 to that in 2011?
Keep it short and to the point. 0.96. What is the ratio of the Number of teachers of Other small states in 2010 to that in 2012?
Give a very brief answer. 0.95. What is the ratio of the Number of teachers in Saudi Arabia in 2010 to that in 2012?
Provide a short and direct response. 0.94. What is the ratio of the Number of teachers in Sri Lanka in 2010 to that in 2012?
Provide a short and direct response. 1. What is the ratio of the Number of teachers in Tonga in 2010 to that in 2012?
Your answer should be very brief. 0.83. What is the ratio of the Number of teachers of Other small states in 2011 to that in 2012?
Provide a short and direct response. 0.97. What is the ratio of the Number of teachers in Saudi Arabia in 2011 to that in 2012?
Provide a short and direct response. 0.96. What is the ratio of the Number of teachers of Tonga in 2011 to that in 2012?
Your answer should be very brief. 0.87. What is the difference between the highest and the second highest Number of teachers in Other small states?
Provide a short and direct response. 3005.89. What is the difference between the highest and the second highest Number of teachers of Saudi Arabia?
Ensure brevity in your answer.  1.16e+04. What is the difference between the highest and the second highest Number of teachers of Sri Lanka?
Keep it short and to the point. 1357. What is the difference between the highest and the second highest Number of teachers in Tonga?
Provide a short and direct response. 23. What is the difference between the highest and the lowest Number of teachers of Other small states?
Make the answer very short. 2.04e+04. What is the difference between the highest and the lowest Number of teachers of Saudi Arabia?
Provide a short and direct response. 4.23e+04. What is the difference between the highest and the lowest Number of teachers in Sri Lanka?
Keep it short and to the point. 5357. What is the difference between the highest and the lowest Number of teachers of Tonga?
Keep it short and to the point. 174. 